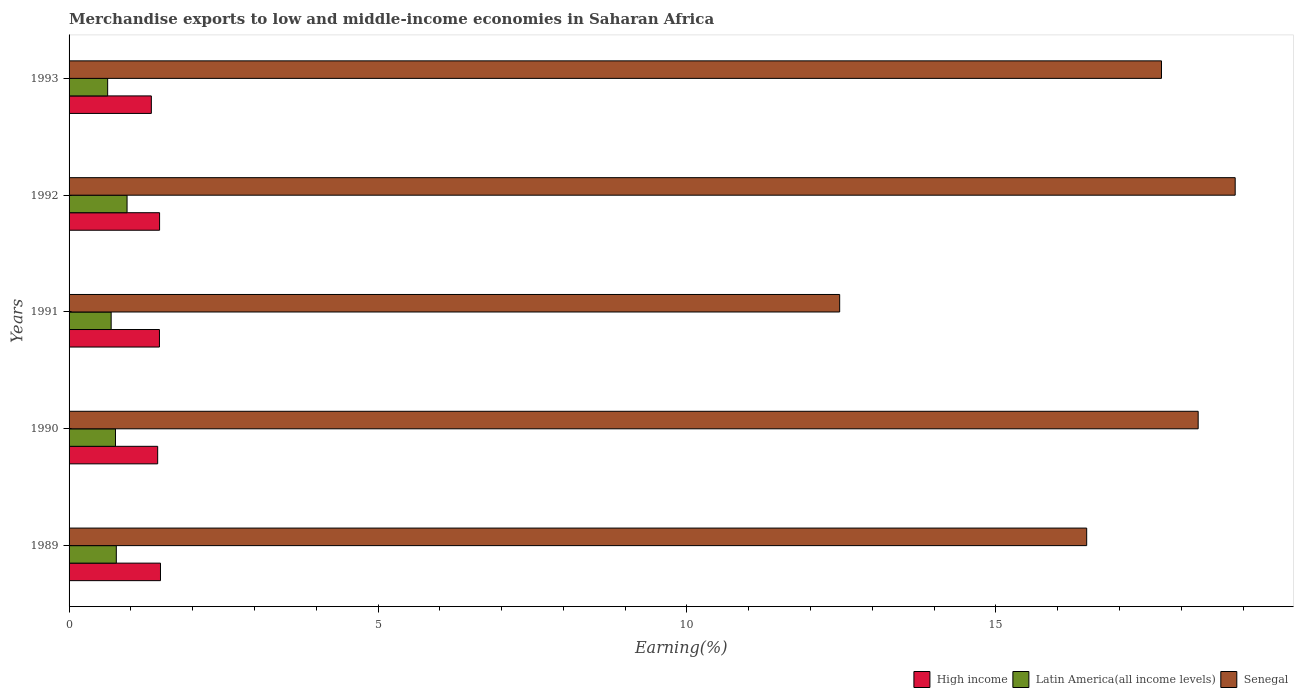How many groups of bars are there?
Offer a terse response. 5. Are the number of bars per tick equal to the number of legend labels?
Provide a succinct answer. Yes. Are the number of bars on each tick of the Y-axis equal?
Offer a very short reply. Yes. How many bars are there on the 1st tick from the top?
Provide a succinct answer. 3. How many bars are there on the 5th tick from the bottom?
Your answer should be compact. 3. What is the label of the 3rd group of bars from the top?
Make the answer very short. 1991. In how many cases, is the number of bars for a given year not equal to the number of legend labels?
Provide a succinct answer. 0. What is the percentage of amount earned from merchandise exports in Senegal in 1990?
Provide a short and direct response. 18.27. Across all years, what is the maximum percentage of amount earned from merchandise exports in High income?
Provide a short and direct response. 1.48. Across all years, what is the minimum percentage of amount earned from merchandise exports in High income?
Make the answer very short. 1.33. In which year was the percentage of amount earned from merchandise exports in Latin America(all income levels) minimum?
Give a very brief answer. 1993. What is the total percentage of amount earned from merchandise exports in Latin America(all income levels) in the graph?
Provide a short and direct response. 3.76. What is the difference between the percentage of amount earned from merchandise exports in Senegal in 1991 and that in 1993?
Provide a succinct answer. -5.21. What is the difference between the percentage of amount earned from merchandise exports in High income in 1993 and the percentage of amount earned from merchandise exports in Senegal in 1989?
Your answer should be compact. -15.14. What is the average percentage of amount earned from merchandise exports in Senegal per year?
Provide a succinct answer. 16.75. In the year 1993, what is the difference between the percentage of amount earned from merchandise exports in High income and percentage of amount earned from merchandise exports in Latin America(all income levels)?
Give a very brief answer. 0.71. In how many years, is the percentage of amount earned from merchandise exports in Senegal greater than 15 %?
Make the answer very short. 4. What is the ratio of the percentage of amount earned from merchandise exports in Senegal in 1992 to that in 1993?
Give a very brief answer. 1.07. Is the percentage of amount earned from merchandise exports in Senegal in 1992 less than that in 1993?
Offer a terse response. No. What is the difference between the highest and the second highest percentage of amount earned from merchandise exports in Latin America(all income levels)?
Offer a very short reply. 0.17. What is the difference between the highest and the lowest percentage of amount earned from merchandise exports in Senegal?
Offer a very short reply. 6.4. What does the 3rd bar from the top in 1990 represents?
Ensure brevity in your answer.  High income. What does the 3rd bar from the bottom in 1993 represents?
Make the answer very short. Senegal. Are all the bars in the graph horizontal?
Make the answer very short. Yes. How many legend labels are there?
Your answer should be compact. 3. How are the legend labels stacked?
Your answer should be very brief. Horizontal. What is the title of the graph?
Your answer should be very brief. Merchandise exports to low and middle-income economies in Saharan Africa. Does "Dominica" appear as one of the legend labels in the graph?
Offer a terse response. No. What is the label or title of the X-axis?
Provide a succinct answer. Earning(%). What is the Earning(%) in High income in 1989?
Offer a very short reply. 1.48. What is the Earning(%) in Latin America(all income levels) in 1989?
Your answer should be compact. 0.76. What is the Earning(%) in Senegal in 1989?
Your answer should be compact. 16.47. What is the Earning(%) of High income in 1990?
Your answer should be very brief. 1.43. What is the Earning(%) in Latin America(all income levels) in 1990?
Your response must be concise. 0.75. What is the Earning(%) of Senegal in 1990?
Keep it short and to the point. 18.27. What is the Earning(%) in High income in 1991?
Keep it short and to the point. 1.46. What is the Earning(%) in Latin America(all income levels) in 1991?
Your answer should be compact. 0.68. What is the Earning(%) of Senegal in 1991?
Offer a very short reply. 12.47. What is the Earning(%) of High income in 1992?
Your answer should be very brief. 1.46. What is the Earning(%) in Latin America(all income levels) in 1992?
Your response must be concise. 0.94. What is the Earning(%) of Senegal in 1992?
Ensure brevity in your answer.  18.87. What is the Earning(%) in High income in 1993?
Provide a short and direct response. 1.33. What is the Earning(%) of Latin America(all income levels) in 1993?
Your answer should be compact. 0.62. What is the Earning(%) of Senegal in 1993?
Your answer should be very brief. 17.68. Across all years, what is the maximum Earning(%) of High income?
Your answer should be very brief. 1.48. Across all years, what is the maximum Earning(%) in Latin America(all income levels)?
Provide a succinct answer. 0.94. Across all years, what is the maximum Earning(%) in Senegal?
Your answer should be compact. 18.87. Across all years, what is the minimum Earning(%) in High income?
Your response must be concise. 1.33. Across all years, what is the minimum Earning(%) of Latin America(all income levels)?
Ensure brevity in your answer.  0.62. Across all years, what is the minimum Earning(%) in Senegal?
Make the answer very short. 12.47. What is the total Earning(%) in High income in the graph?
Ensure brevity in your answer.  7.17. What is the total Earning(%) in Latin America(all income levels) in the graph?
Give a very brief answer. 3.76. What is the total Earning(%) of Senegal in the graph?
Offer a terse response. 83.76. What is the difference between the Earning(%) of High income in 1989 and that in 1990?
Offer a terse response. 0.05. What is the difference between the Earning(%) in Latin America(all income levels) in 1989 and that in 1990?
Offer a terse response. 0.01. What is the difference between the Earning(%) of Senegal in 1989 and that in 1990?
Your response must be concise. -1.8. What is the difference between the Earning(%) in High income in 1989 and that in 1991?
Your answer should be compact. 0.02. What is the difference between the Earning(%) in Latin America(all income levels) in 1989 and that in 1991?
Make the answer very short. 0.08. What is the difference between the Earning(%) in Senegal in 1989 and that in 1991?
Your answer should be very brief. 4. What is the difference between the Earning(%) of High income in 1989 and that in 1992?
Your answer should be very brief. 0.01. What is the difference between the Earning(%) of Latin America(all income levels) in 1989 and that in 1992?
Provide a succinct answer. -0.17. What is the difference between the Earning(%) of Senegal in 1989 and that in 1992?
Offer a terse response. -2.4. What is the difference between the Earning(%) of High income in 1989 and that in 1993?
Offer a very short reply. 0.15. What is the difference between the Earning(%) in Latin America(all income levels) in 1989 and that in 1993?
Offer a very short reply. 0.14. What is the difference between the Earning(%) of Senegal in 1989 and that in 1993?
Your answer should be very brief. -1.21. What is the difference between the Earning(%) of High income in 1990 and that in 1991?
Your answer should be compact. -0.03. What is the difference between the Earning(%) in Latin America(all income levels) in 1990 and that in 1991?
Ensure brevity in your answer.  0.07. What is the difference between the Earning(%) in Senegal in 1990 and that in 1991?
Ensure brevity in your answer.  5.8. What is the difference between the Earning(%) in High income in 1990 and that in 1992?
Offer a terse response. -0.03. What is the difference between the Earning(%) in Latin America(all income levels) in 1990 and that in 1992?
Your answer should be compact. -0.19. What is the difference between the Earning(%) in Senegal in 1990 and that in 1992?
Provide a succinct answer. -0.6. What is the difference between the Earning(%) in High income in 1990 and that in 1993?
Your answer should be compact. 0.1. What is the difference between the Earning(%) of Latin America(all income levels) in 1990 and that in 1993?
Provide a short and direct response. 0.13. What is the difference between the Earning(%) in Senegal in 1990 and that in 1993?
Offer a very short reply. 0.59. What is the difference between the Earning(%) in High income in 1991 and that in 1992?
Your answer should be compact. -0. What is the difference between the Earning(%) of Latin America(all income levels) in 1991 and that in 1992?
Keep it short and to the point. -0.26. What is the difference between the Earning(%) in Senegal in 1991 and that in 1992?
Ensure brevity in your answer.  -6.4. What is the difference between the Earning(%) of High income in 1991 and that in 1993?
Offer a very short reply. 0.13. What is the difference between the Earning(%) in Latin America(all income levels) in 1991 and that in 1993?
Provide a short and direct response. 0.06. What is the difference between the Earning(%) of Senegal in 1991 and that in 1993?
Offer a very short reply. -5.21. What is the difference between the Earning(%) in High income in 1992 and that in 1993?
Provide a short and direct response. 0.13. What is the difference between the Earning(%) of Latin America(all income levels) in 1992 and that in 1993?
Make the answer very short. 0.31. What is the difference between the Earning(%) in Senegal in 1992 and that in 1993?
Keep it short and to the point. 1.19. What is the difference between the Earning(%) in High income in 1989 and the Earning(%) in Latin America(all income levels) in 1990?
Your answer should be very brief. 0.73. What is the difference between the Earning(%) of High income in 1989 and the Earning(%) of Senegal in 1990?
Ensure brevity in your answer.  -16.79. What is the difference between the Earning(%) of Latin America(all income levels) in 1989 and the Earning(%) of Senegal in 1990?
Give a very brief answer. -17.51. What is the difference between the Earning(%) in High income in 1989 and the Earning(%) in Latin America(all income levels) in 1991?
Provide a succinct answer. 0.8. What is the difference between the Earning(%) of High income in 1989 and the Earning(%) of Senegal in 1991?
Your response must be concise. -10.99. What is the difference between the Earning(%) of Latin America(all income levels) in 1989 and the Earning(%) of Senegal in 1991?
Keep it short and to the point. -11.71. What is the difference between the Earning(%) of High income in 1989 and the Earning(%) of Latin America(all income levels) in 1992?
Offer a terse response. 0.54. What is the difference between the Earning(%) in High income in 1989 and the Earning(%) in Senegal in 1992?
Your answer should be compact. -17.39. What is the difference between the Earning(%) in Latin America(all income levels) in 1989 and the Earning(%) in Senegal in 1992?
Provide a short and direct response. -18.11. What is the difference between the Earning(%) in High income in 1989 and the Earning(%) in Latin America(all income levels) in 1993?
Provide a succinct answer. 0.85. What is the difference between the Earning(%) in High income in 1989 and the Earning(%) in Senegal in 1993?
Your response must be concise. -16.2. What is the difference between the Earning(%) of Latin America(all income levels) in 1989 and the Earning(%) of Senegal in 1993?
Offer a terse response. -16.91. What is the difference between the Earning(%) of High income in 1990 and the Earning(%) of Latin America(all income levels) in 1991?
Make the answer very short. 0.75. What is the difference between the Earning(%) in High income in 1990 and the Earning(%) in Senegal in 1991?
Your response must be concise. -11.04. What is the difference between the Earning(%) of Latin America(all income levels) in 1990 and the Earning(%) of Senegal in 1991?
Offer a very short reply. -11.72. What is the difference between the Earning(%) in High income in 1990 and the Earning(%) in Latin America(all income levels) in 1992?
Keep it short and to the point. 0.5. What is the difference between the Earning(%) in High income in 1990 and the Earning(%) in Senegal in 1992?
Your response must be concise. -17.44. What is the difference between the Earning(%) of Latin America(all income levels) in 1990 and the Earning(%) of Senegal in 1992?
Ensure brevity in your answer.  -18.12. What is the difference between the Earning(%) in High income in 1990 and the Earning(%) in Latin America(all income levels) in 1993?
Your answer should be compact. 0.81. What is the difference between the Earning(%) in High income in 1990 and the Earning(%) in Senegal in 1993?
Your answer should be compact. -16.25. What is the difference between the Earning(%) of Latin America(all income levels) in 1990 and the Earning(%) of Senegal in 1993?
Ensure brevity in your answer.  -16.93. What is the difference between the Earning(%) in High income in 1991 and the Earning(%) in Latin America(all income levels) in 1992?
Offer a terse response. 0.52. What is the difference between the Earning(%) of High income in 1991 and the Earning(%) of Senegal in 1992?
Offer a terse response. -17.41. What is the difference between the Earning(%) in Latin America(all income levels) in 1991 and the Earning(%) in Senegal in 1992?
Give a very brief answer. -18.19. What is the difference between the Earning(%) in High income in 1991 and the Earning(%) in Latin America(all income levels) in 1993?
Your answer should be compact. 0.84. What is the difference between the Earning(%) of High income in 1991 and the Earning(%) of Senegal in 1993?
Make the answer very short. -16.22. What is the difference between the Earning(%) of Latin America(all income levels) in 1991 and the Earning(%) of Senegal in 1993?
Offer a very short reply. -17. What is the difference between the Earning(%) in High income in 1992 and the Earning(%) in Latin America(all income levels) in 1993?
Keep it short and to the point. 0.84. What is the difference between the Earning(%) of High income in 1992 and the Earning(%) of Senegal in 1993?
Ensure brevity in your answer.  -16.21. What is the difference between the Earning(%) of Latin America(all income levels) in 1992 and the Earning(%) of Senegal in 1993?
Offer a terse response. -16.74. What is the average Earning(%) in High income per year?
Give a very brief answer. 1.43. What is the average Earning(%) in Latin America(all income levels) per year?
Your answer should be very brief. 0.75. What is the average Earning(%) of Senegal per year?
Give a very brief answer. 16.75. In the year 1989, what is the difference between the Earning(%) in High income and Earning(%) in Latin America(all income levels)?
Make the answer very short. 0.71. In the year 1989, what is the difference between the Earning(%) in High income and Earning(%) in Senegal?
Your answer should be compact. -14.99. In the year 1989, what is the difference between the Earning(%) in Latin America(all income levels) and Earning(%) in Senegal?
Make the answer very short. -15.7. In the year 1990, what is the difference between the Earning(%) of High income and Earning(%) of Latin America(all income levels)?
Give a very brief answer. 0.68. In the year 1990, what is the difference between the Earning(%) in High income and Earning(%) in Senegal?
Keep it short and to the point. -16.84. In the year 1990, what is the difference between the Earning(%) of Latin America(all income levels) and Earning(%) of Senegal?
Make the answer very short. -17.52. In the year 1991, what is the difference between the Earning(%) in High income and Earning(%) in Latin America(all income levels)?
Your response must be concise. 0.78. In the year 1991, what is the difference between the Earning(%) of High income and Earning(%) of Senegal?
Provide a succinct answer. -11.01. In the year 1991, what is the difference between the Earning(%) of Latin America(all income levels) and Earning(%) of Senegal?
Provide a short and direct response. -11.79. In the year 1992, what is the difference between the Earning(%) in High income and Earning(%) in Latin America(all income levels)?
Your answer should be very brief. 0.53. In the year 1992, what is the difference between the Earning(%) of High income and Earning(%) of Senegal?
Your response must be concise. -17.41. In the year 1992, what is the difference between the Earning(%) of Latin America(all income levels) and Earning(%) of Senegal?
Provide a succinct answer. -17.93. In the year 1993, what is the difference between the Earning(%) of High income and Earning(%) of Latin America(all income levels)?
Give a very brief answer. 0.71. In the year 1993, what is the difference between the Earning(%) of High income and Earning(%) of Senegal?
Make the answer very short. -16.35. In the year 1993, what is the difference between the Earning(%) in Latin America(all income levels) and Earning(%) in Senegal?
Provide a succinct answer. -17.05. What is the ratio of the Earning(%) of High income in 1989 to that in 1990?
Your response must be concise. 1.03. What is the ratio of the Earning(%) of Latin America(all income levels) in 1989 to that in 1990?
Your response must be concise. 1.02. What is the ratio of the Earning(%) in Senegal in 1989 to that in 1990?
Give a very brief answer. 0.9. What is the ratio of the Earning(%) in High income in 1989 to that in 1991?
Make the answer very short. 1.01. What is the ratio of the Earning(%) in Latin America(all income levels) in 1989 to that in 1991?
Provide a succinct answer. 1.12. What is the ratio of the Earning(%) of Senegal in 1989 to that in 1991?
Your response must be concise. 1.32. What is the ratio of the Earning(%) in High income in 1989 to that in 1992?
Keep it short and to the point. 1.01. What is the ratio of the Earning(%) in Latin America(all income levels) in 1989 to that in 1992?
Your response must be concise. 0.81. What is the ratio of the Earning(%) in Senegal in 1989 to that in 1992?
Your answer should be compact. 0.87. What is the ratio of the Earning(%) of High income in 1989 to that in 1993?
Offer a very short reply. 1.11. What is the ratio of the Earning(%) in Latin America(all income levels) in 1989 to that in 1993?
Provide a short and direct response. 1.22. What is the ratio of the Earning(%) of Senegal in 1989 to that in 1993?
Give a very brief answer. 0.93. What is the ratio of the Earning(%) in High income in 1990 to that in 1991?
Provide a succinct answer. 0.98. What is the ratio of the Earning(%) of Latin America(all income levels) in 1990 to that in 1991?
Provide a short and direct response. 1.1. What is the ratio of the Earning(%) of Senegal in 1990 to that in 1991?
Offer a very short reply. 1.47. What is the ratio of the Earning(%) in High income in 1990 to that in 1992?
Offer a very short reply. 0.98. What is the ratio of the Earning(%) in Latin America(all income levels) in 1990 to that in 1992?
Your answer should be very brief. 0.8. What is the ratio of the Earning(%) of Senegal in 1990 to that in 1992?
Keep it short and to the point. 0.97. What is the ratio of the Earning(%) of Latin America(all income levels) in 1990 to that in 1993?
Provide a succinct answer. 1.2. What is the ratio of the Earning(%) in Senegal in 1990 to that in 1993?
Your answer should be compact. 1.03. What is the ratio of the Earning(%) of Latin America(all income levels) in 1991 to that in 1992?
Offer a very short reply. 0.73. What is the ratio of the Earning(%) of Senegal in 1991 to that in 1992?
Keep it short and to the point. 0.66. What is the ratio of the Earning(%) of High income in 1991 to that in 1993?
Your answer should be compact. 1.1. What is the ratio of the Earning(%) in Latin America(all income levels) in 1991 to that in 1993?
Your response must be concise. 1.09. What is the ratio of the Earning(%) in Senegal in 1991 to that in 1993?
Provide a succinct answer. 0.71. What is the ratio of the Earning(%) in High income in 1992 to that in 1993?
Offer a very short reply. 1.1. What is the ratio of the Earning(%) of Latin America(all income levels) in 1992 to that in 1993?
Your answer should be compact. 1.5. What is the ratio of the Earning(%) in Senegal in 1992 to that in 1993?
Make the answer very short. 1.07. What is the difference between the highest and the second highest Earning(%) of High income?
Your response must be concise. 0.01. What is the difference between the highest and the second highest Earning(%) of Latin America(all income levels)?
Give a very brief answer. 0.17. What is the difference between the highest and the second highest Earning(%) in Senegal?
Your response must be concise. 0.6. What is the difference between the highest and the lowest Earning(%) in High income?
Provide a short and direct response. 0.15. What is the difference between the highest and the lowest Earning(%) of Latin America(all income levels)?
Keep it short and to the point. 0.31. What is the difference between the highest and the lowest Earning(%) of Senegal?
Keep it short and to the point. 6.4. 